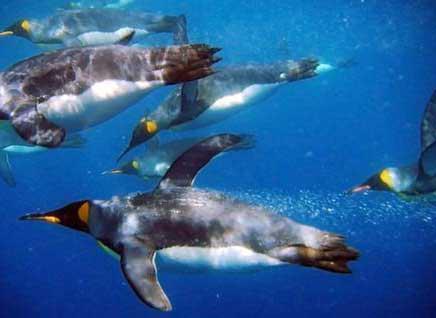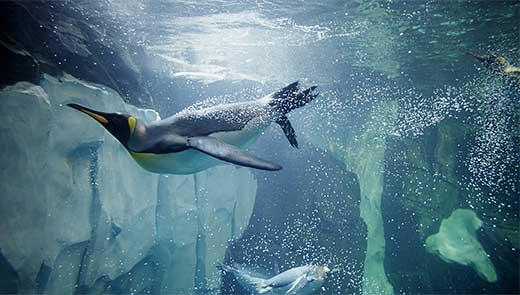The first image is the image on the left, the second image is the image on the right. For the images displayed, is the sentence "An image shows exactly one penguin, which is swimming leftward in front of rocky structures." factually correct? Answer yes or no. Yes. The first image is the image on the left, the second image is the image on the right. Considering the images on both sides, is "A single penguin is swimming to the left in one of the images." valid? Answer yes or no. Yes. 